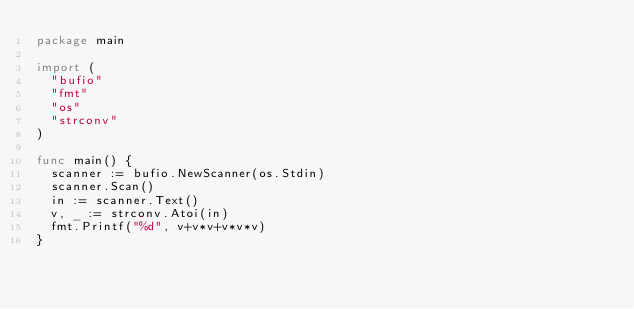<code> <loc_0><loc_0><loc_500><loc_500><_Go_>package main

import (
	"bufio"
	"fmt"
	"os"
	"strconv"
)

func main() {
	scanner := bufio.NewScanner(os.Stdin)
	scanner.Scan()
	in := scanner.Text()
	v, _ := strconv.Atoi(in)
	fmt.Printf("%d", v+v*v+v*v*v)
}</code> 